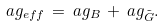<formula> <loc_0><loc_0><loc_500><loc_500>\L a g _ { e f f } \, = \, \L a g _ { B } \, + \, \L a g _ { \tilde { G } } .</formula> 